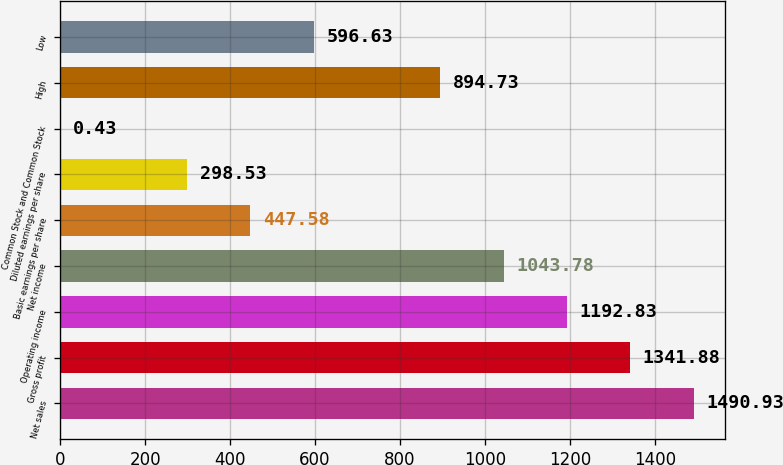Convert chart to OTSL. <chart><loc_0><loc_0><loc_500><loc_500><bar_chart><fcel>Net sales<fcel>Gross profit<fcel>Operating income<fcel>Net income<fcel>Basic earnings per share<fcel>Diluted earnings per share<fcel>Common Stock and Common Stock<fcel>High<fcel>Low<nl><fcel>1490.93<fcel>1341.88<fcel>1192.83<fcel>1043.78<fcel>447.58<fcel>298.53<fcel>0.43<fcel>894.73<fcel>596.63<nl></chart> 